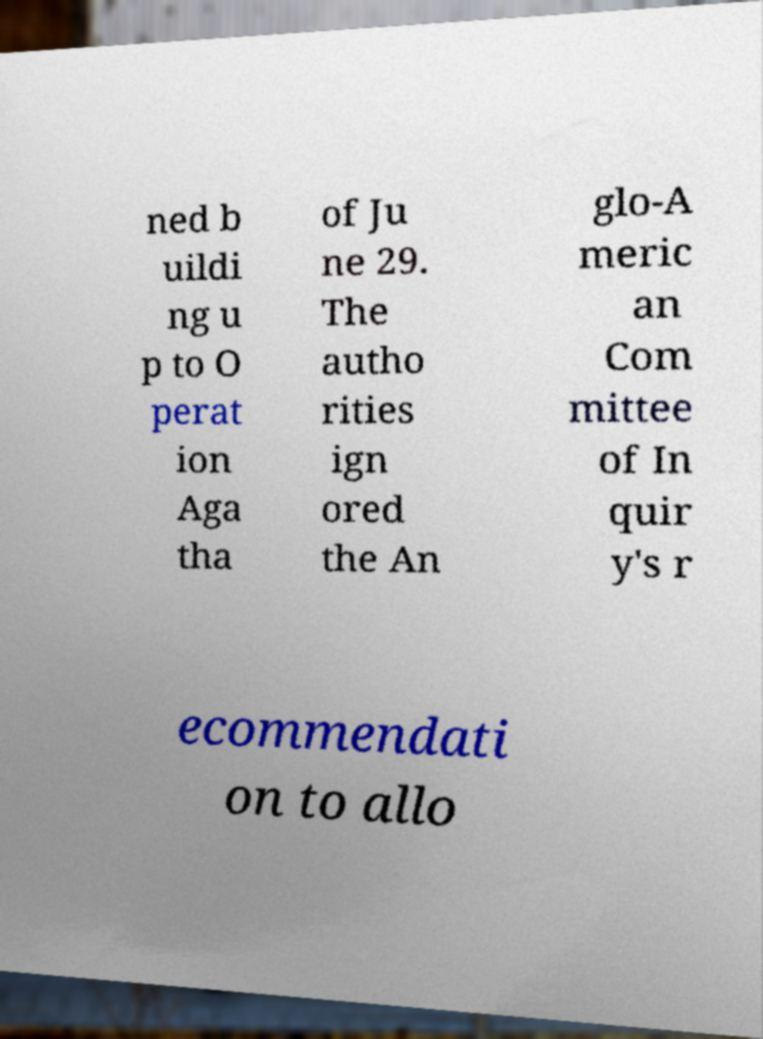Can you read and provide the text displayed in the image?This photo seems to have some interesting text. Can you extract and type it out for me? ned b uildi ng u p to O perat ion Aga tha of Ju ne 29. The autho rities ign ored the An glo-A meric an Com mittee of In quir y's r ecommendati on to allo 